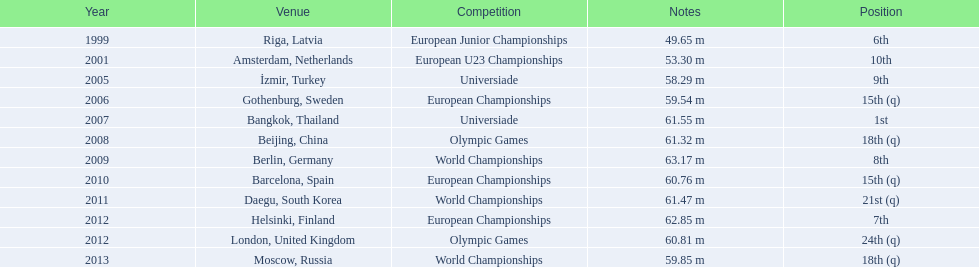What were the distances of mayer's throws? 49.65 m, 53.30 m, 58.29 m, 59.54 m, 61.55 m, 61.32 m, 63.17 m, 60.76 m, 61.47 m, 62.85 m, 60.81 m, 59.85 m. Which of these went the farthest? 63.17 m. 